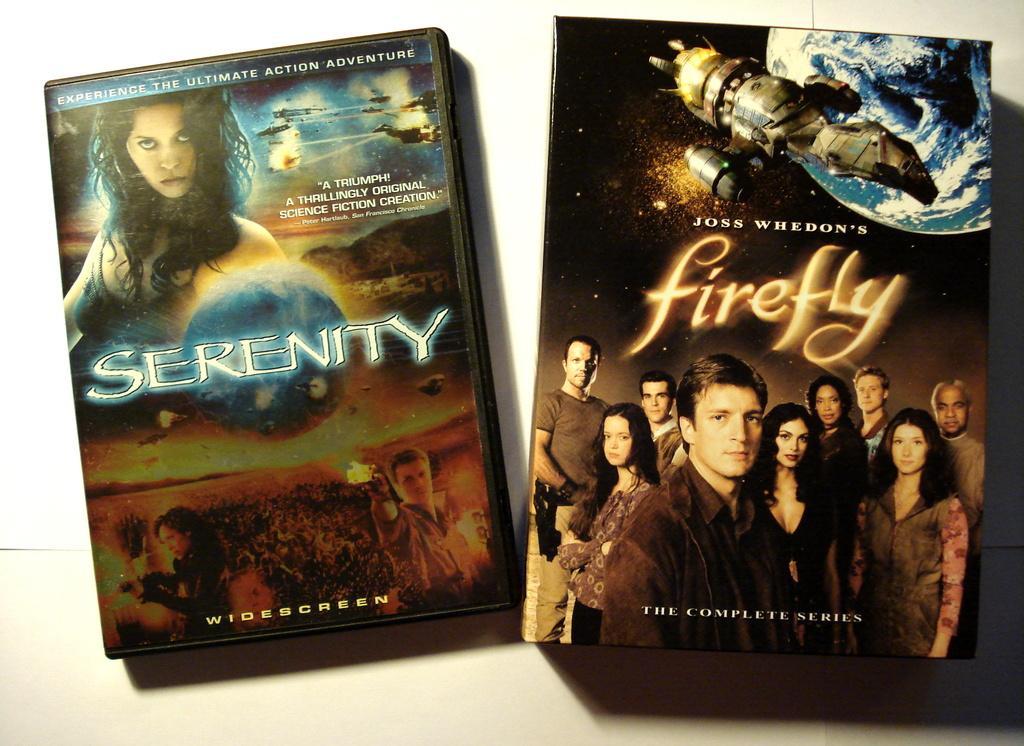How would you summarize this image in a sentence or two? In this picture we can see two DVD boxes, on the right side box we can see depictions of persons, a satellite and the earth, on the left side box we can see depictions of persons, there is some text here. 